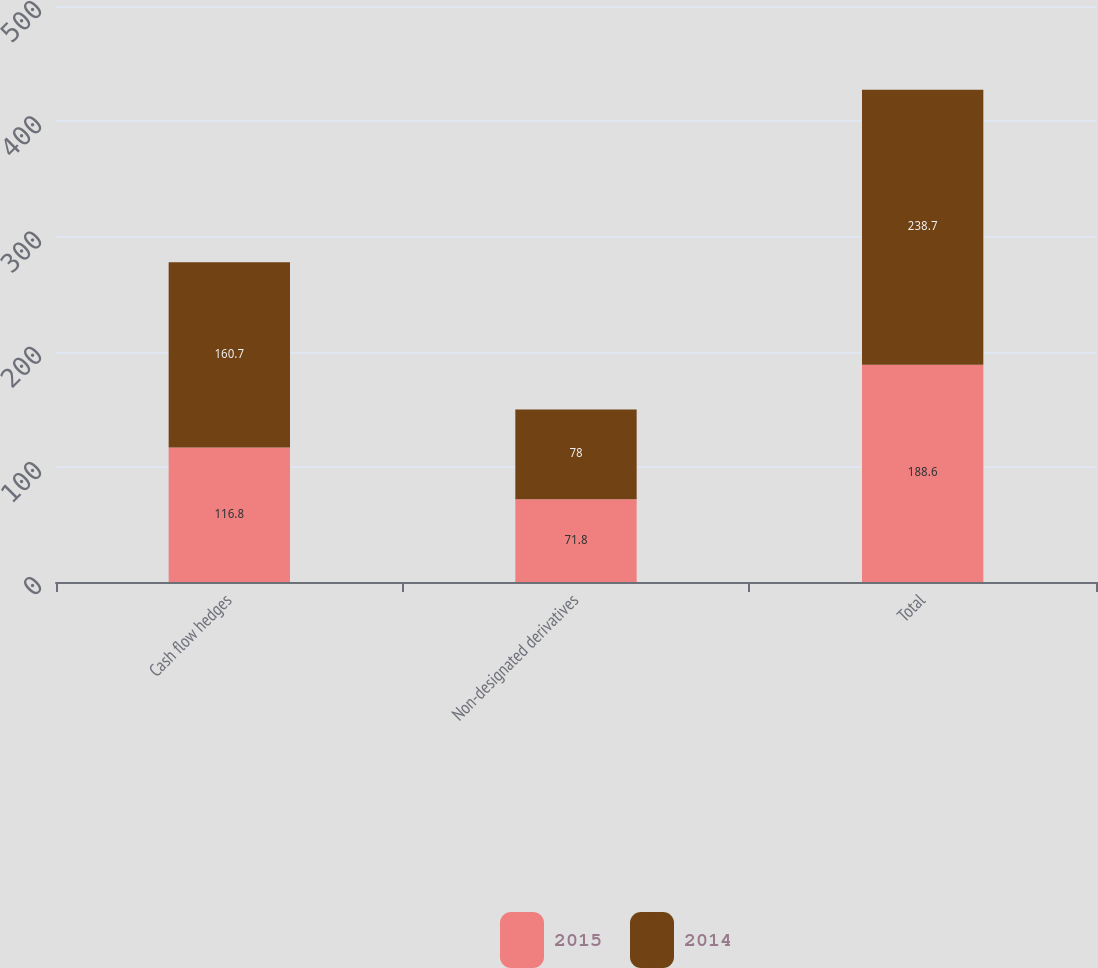Convert chart to OTSL. <chart><loc_0><loc_0><loc_500><loc_500><stacked_bar_chart><ecel><fcel>Cash flow hedges<fcel>Non-designated derivatives<fcel>Total<nl><fcel>2015<fcel>116.8<fcel>71.8<fcel>188.6<nl><fcel>2014<fcel>160.7<fcel>78<fcel>238.7<nl></chart> 